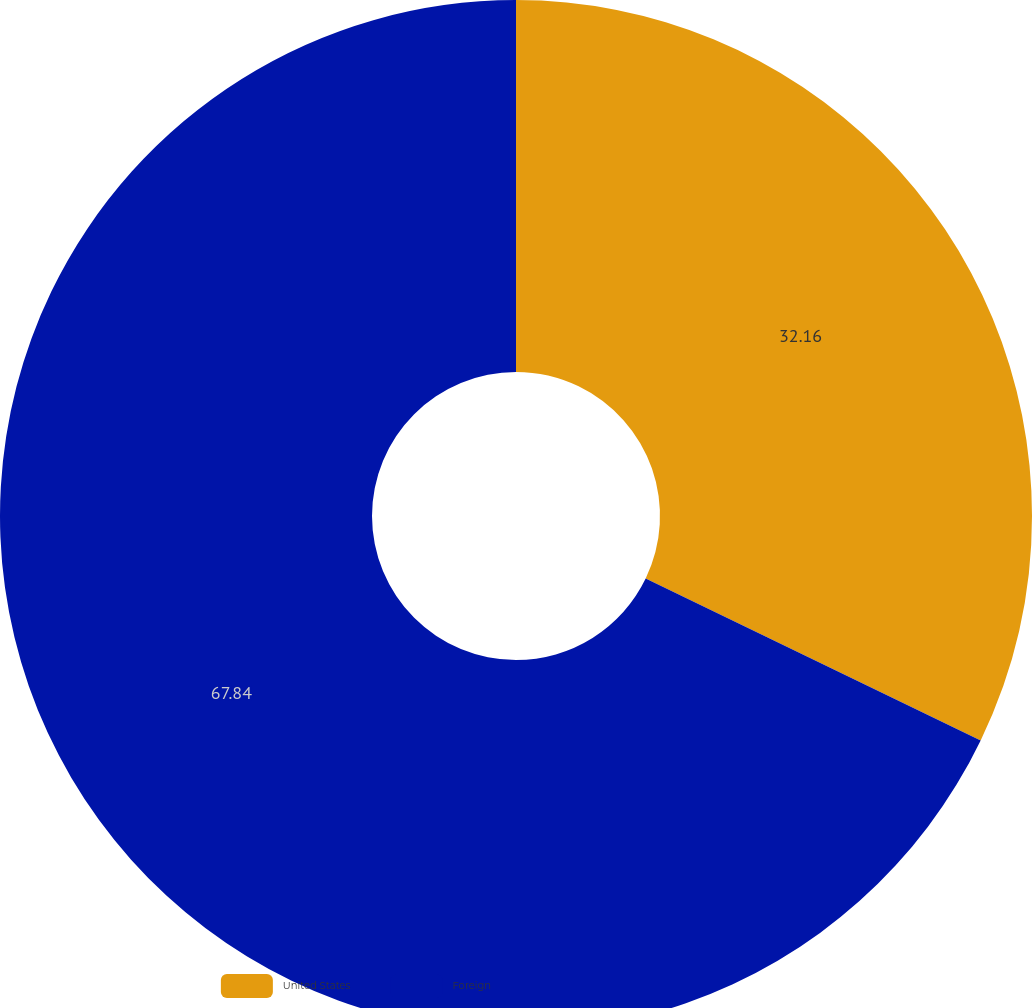Convert chart. <chart><loc_0><loc_0><loc_500><loc_500><pie_chart><fcel>United States<fcel>Foreign<nl><fcel>32.16%<fcel>67.84%<nl></chart> 